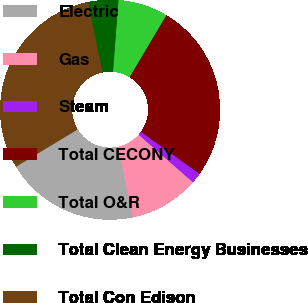<chart> <loc_0><loc_0><loc_500><loc_500><pie_chart><fcel>Electric<fcel>Gas<fcel>Steam<fcel>Total CECONY<fcel>Total O&R<fcel>Total Clean Energy Businesses<fcel>Total Con Edison<nl><fcel>19.66%<fcel>10.22%<fcel>1.56%<fcel>26.35%<fcel>7.33%<fcel>4.44%<fcel>30.43%<nl></chart> 